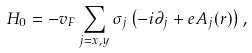<formula> <loc_0><loc_0><loc_500><loc_500>H _ { 0 } = - v _ { F } \sum _ { j = x , y } \sigma _ { j } \left ( - i \partial _ { j } + e A _ { j } ( r ) \right ) ,</formula> 